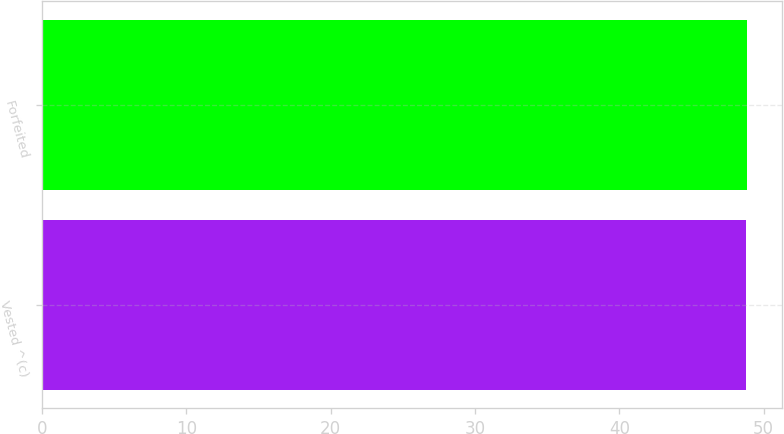Convert chart to OTSL. <chart><loc_0><loc_0><loc_500><loc_500><bar_chart><fcel>Vested ^(c)<fcel>Forfeited<nl><fcel>48.81<fcel>48.84<nl></chart> 